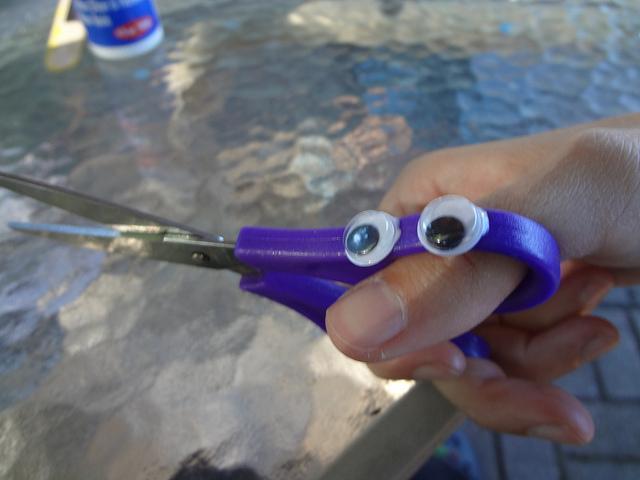How many water ski board have yellow lights shedding on them?
Give a very brief answer. 0. 